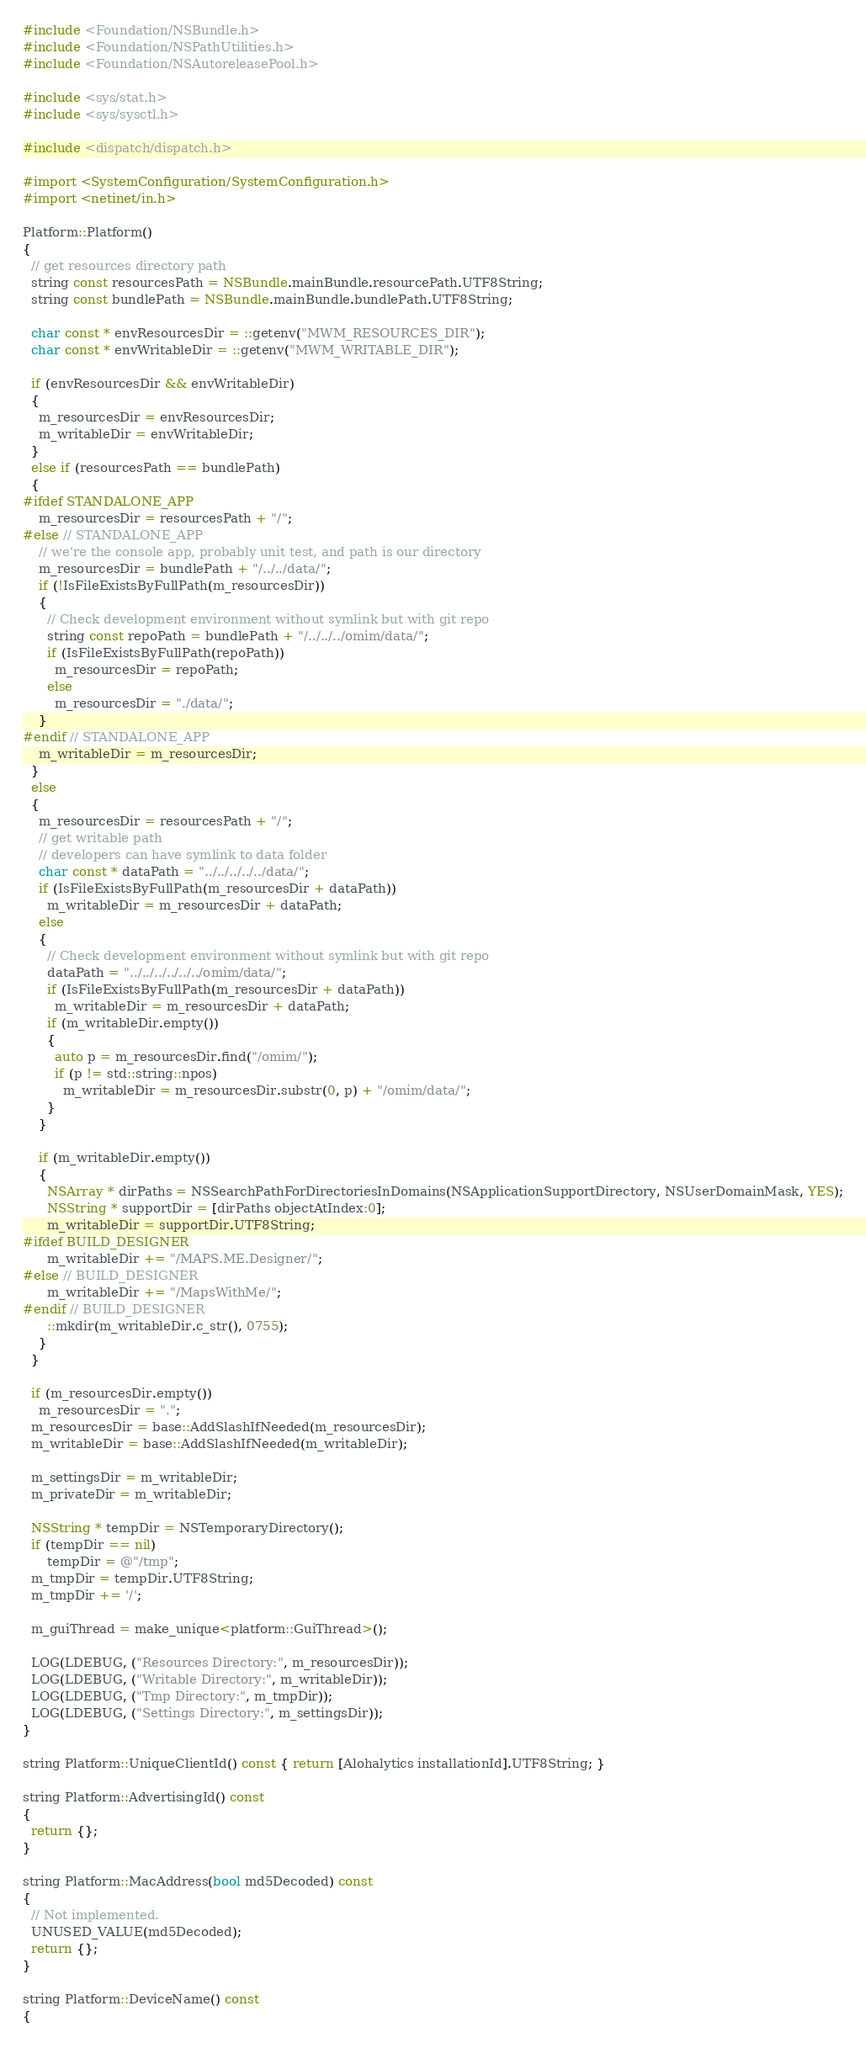<code> <loc_0><loc_0><loc_500><loc_500><_ObjectiveC_>#include <Foundation/NSBundle.h>
#include <Foundation/NSPathUtilities.h>
#include <Foundation/NSAutoreleasePool.h>

#include <sys/stat.h>
#include <sys/sysctl.h>

#include <dispatch/dispatch.h>

#import <SystemConfiguration/SystemConfiguration.h>
#import <netinet/in.h>

Platform::Platform()
{
  // get resources directory path
  string const resourcesPath = NSBundle.mainBundle.resourcePath.UTF8String;
  string const bundlePath = NSBundle.mainBundle.bundlePath.UTF8String;

  char const * envResourcesDir = ::getenv("MWM_RESOURCES_DIR");
  char const * envWritableDir = ::getenv("MWM_WRITABLE_DIR");

  if (envResourcesDir && envWritableDir)
  {
    m_resourcesDir = envResourcesDir;
    m_writableDir = envWritableDir;
  }
  else if (resourcesPath == bundlePath)
  {
#ifdef STANDALONE_APP
    m_resourcesDir = resourcesPath + "/";
#else // STANDALONE_APP
    // we're the console app, probably unit test, and path is our directory
    m_resourcesDir = bundlePath + "/../../data/";
    if (!IsFileExistsByFullPath(m_resourcesDir))
    {
      // Check development environment without symlink but with git repo
      string const repoPath = bundlePath + "/../../../omim/data/";
      if (IsFileExistsByFullPath(repoPath))
        m_resourcesDir = repoPath;
      else
        m_resourcesDir = "./data/";
    }
#endif // STANDALONE_APP
    m_writableDir = m_resourcesDir;
  }
  else
  {
    m_resourcesDir = resourcesPath + "/";
    // get writable path
    // developers can have symlink to data folder
    char const * dataPath = "../../../../../data/";
    if (IsFileExistsByFullPath(m_resourcesDir + dataPath))
      m_writableDir = m_resourcesDir + dataPath;
    else
    {
      // Check development environment without symlink but with git repo
      dataPath = "../../../../../../omim/data/";
      if (IsFileExistsByFullPath(m_resourcesDir + dataPath))
        m_writableDir = m_resourcesDir + dataPath;
      if (m_writableDir.empty())
      {
        auto p = m_resourcesDir.find("/omim/");
        if (p != std::string::npos)
          m_writableDir = m_resourcesDir.substr(0, p) + "/omim/data/";
      }
    }

    if (m_writableDir.empty())
    {
      NSArray * dirPaths = NSSearchPathForDirectoriesInDomains(NSApplicationSupportDirectory, NSUserDomainMask, YES);
      NSString * supportDir = [dirPaths objectAtIndex:0];
      m_writableDir = supportDir.UTF8String;
#ifdef BUILD_DESIGNER
      m_writableDir += "/MAPS.ME.Designer/";
#else // BUILD_DESIGNER
      m_writableDir += "/MapsWithMe/";
#endif // BUILD_DESIGNER
      ::mkdir(m_writableDir.c_str(), 0755);
    }
  }

  if (m_resourcesDir.empty())
    m_resourcesDir = ".";
  m_resourcesDir = base::AddSlashIfNeeded(m_resourcesDir);
  m_writableDir = base::AddSlashIfNeeded(m_writableDir);

  m_settingsDir = m_writableDir;
  m_privateDir = m_writableDir;

  NSString * tempDir = NSTemporaryDirectory();
  if (tempDir == nil)
      tempDir = @"/tmp";
  m_tmpDir = tempDir.UTF8String;
  m_tmpDir += '/';

  m_guiThread = make_unique<platform::GuiThread>();

  LOG(LDEBUG, ("Resources Directory:", m_resourcesDir));
  LOG(LDEBUG, ("Writable Directory:", m_writableDir));
  LOG(LDEBUG, ("Tmp Directory:", m_tmpDir));
  LOG(LDEBUG, ("Settings Directory:", m_settingsDir));
}

string Platform::UniqueClientId() const { return [Alohalytics installationId].UTF8String; }

string Platform::AdvertisingId() const
{
  return {};
}

string Platform::MacAddress(bool md5Decoded) const
{
  // Not implemented.
  UNUSED_VALUE(md5Decoded);
  return {};
}

string Platform::DeviceName() const
{</code> 